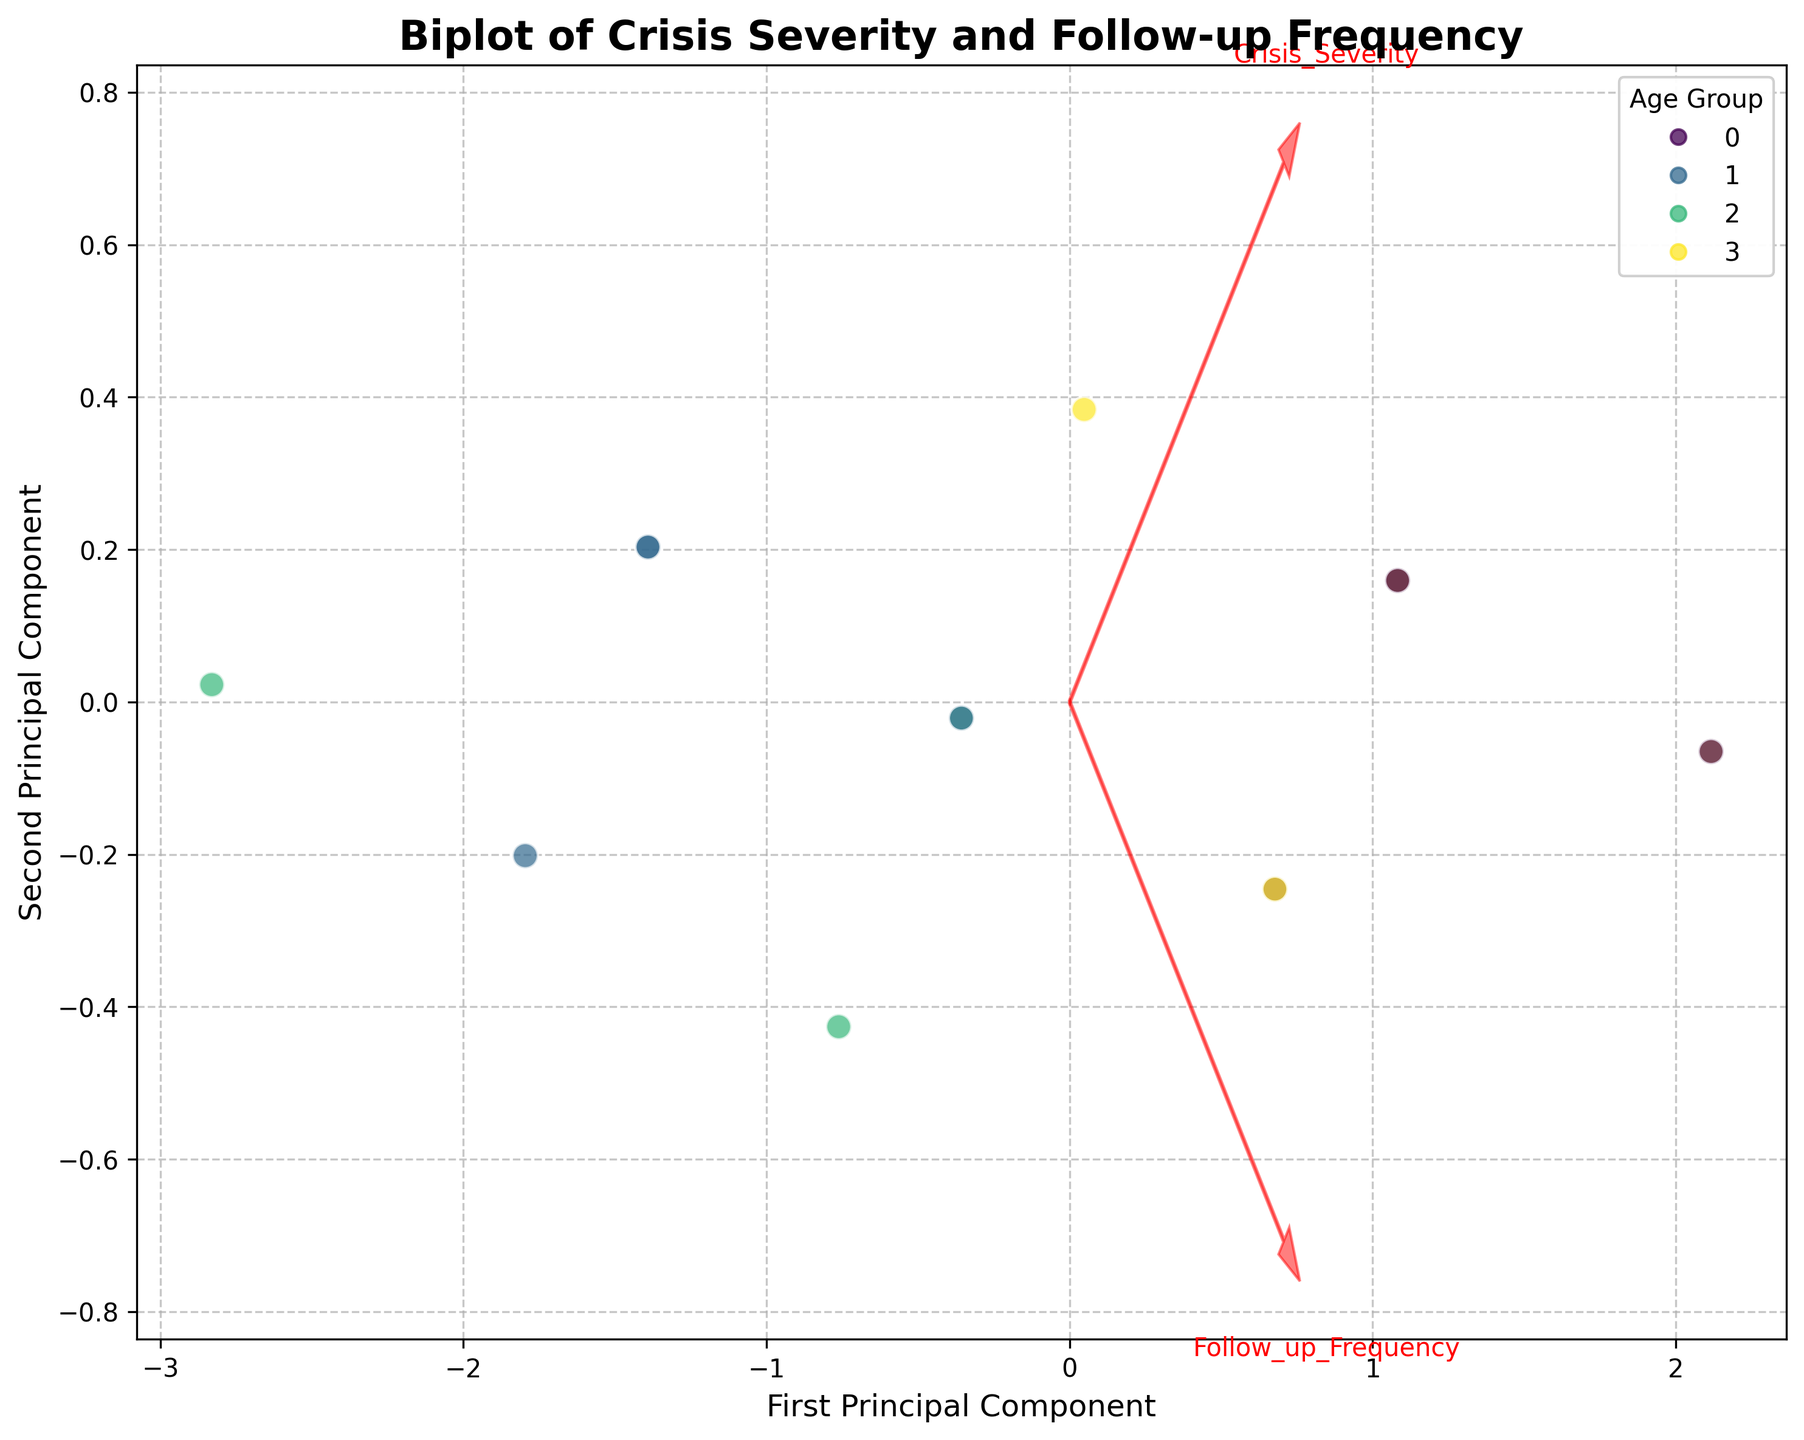what is the title of the figure? The title of the figure is usually positioned at the top and is written in larger, bold text. By reading this text, we can determine the title easily.
Answer: Biplot of Crisis Severity and Follow-up Frequency how many data points are displayed in the plot? The data points are represented by individual markers in the scatter plot. Counting each marker will give the number of data points.
Answer: 15 which component is represented on the x-axis? The label of the x-axis indicates the variable that the axis represents. By looking at this label, we can identify the component.
Answer: First Principal Component which age group has the highest number of follow-up interventions? The color of the data points represents different age groups. By identifying the color corresponding to the highest follow-up frequency values, we can determine which age group it belongs to.
Answer: Elderly what is the direction of the feature vector for "Crisis_Severity"? The feature vectors are represented by arrows. By observing the direction of the arrow labeled "Crisis_Severity," we can determine its direction.
Answer: Pointed towards the right does the "Elderly" age group have more data points clustered towards the right or the left side of the plot? By observing the position of the data points corresponding to the "Elderly" age group color, we can see whether they are mostly on the right or left side.
Answer: Right which age group shows the widest spread along the first principal component? The spread along the first principal component is determined by the range of the x-coordinates of the data points. By comparing the ranges of different age groups, we can determine the one with the widest spread.
Answer: Young Adult is 'Follow_up_Frequency' positively correlated with 'Crisis_Severity'? By looking at the direction and alignment of the 'Follow_up_Frequency' and 'Crisis_Severity' vectors, we can infer whether the correlation is positive or negative.
Answer: Yes do any two age groups have overlapping data points? If yes, which ones? By observing the scatter plot and noting the colors, we can identify if any data points from different age groups overlap.
Answer: Yes, Young Adult and Teenager how do the low-income individuals' data points position in the plot compared to middle-income individuals? By looking at the scatter plot and identifying the color representing each demographic factor's data points, we can compare the positions between low-income and middle-income individuals.
Answer: Low-income individuals are more spread around the plot compared to middle-income individuals who cluster closer together 